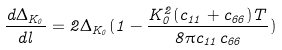Convert formula to latex. <formula><loc_0><loc_0><loc_500><loc_500>\frac { d \Delta _ { K _ { 0 } } } { d l } = 2 \Delta _ { K _ { 0 } } ( 1 - \frac { K _ { 0 } ^ { 2 } ( c _ { 1 1 } + c _ { 6 6 } ) T } { 8 \pi c _ { 1 1 } c _ { 6 6 } } )</formula> 